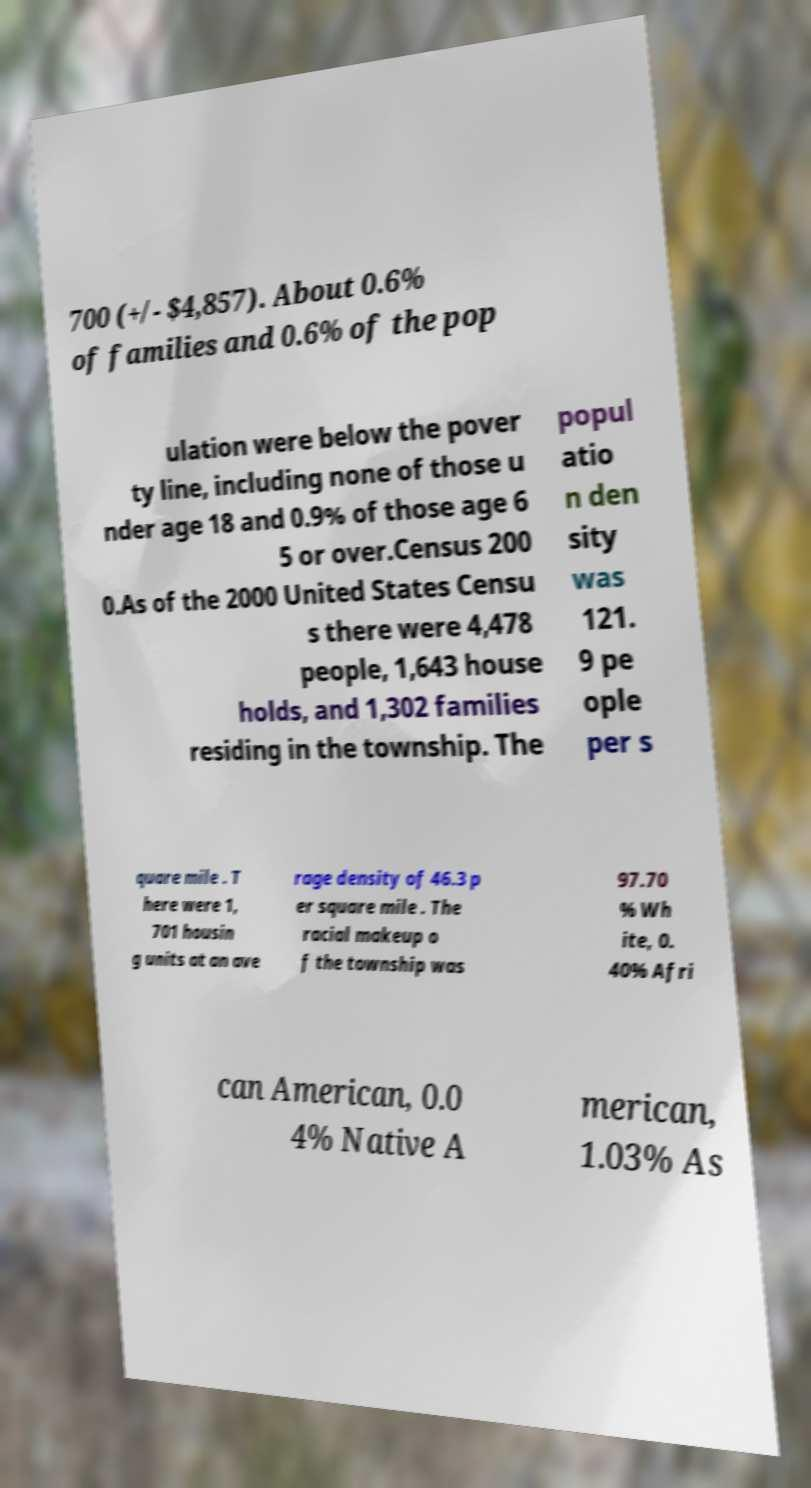What messages or text are displayed in this image? I need them in a readable, typed format. 700 (+/- $4,857). About 0.6% of families and 0.6% of the pop ulation were below the pover ty line, including none of those u nder age 18 and 0.9% of those age 6 5 or over.Census 200 0.As of the 2000 United States Censu s there were 4,478 people, 1,643 house holds, and 1,302 families residing in the township. The popul atio n den sity was 121. 9 pe ople per s quare mile . T here were 1, 701 housin g units at an ave rage density of 46.3 p er square mile . The racial makeup o f the township was 97.70 % Wh ite, 0. 40% Afri can American, 0.0 4% Native A merican, 1.03% As 